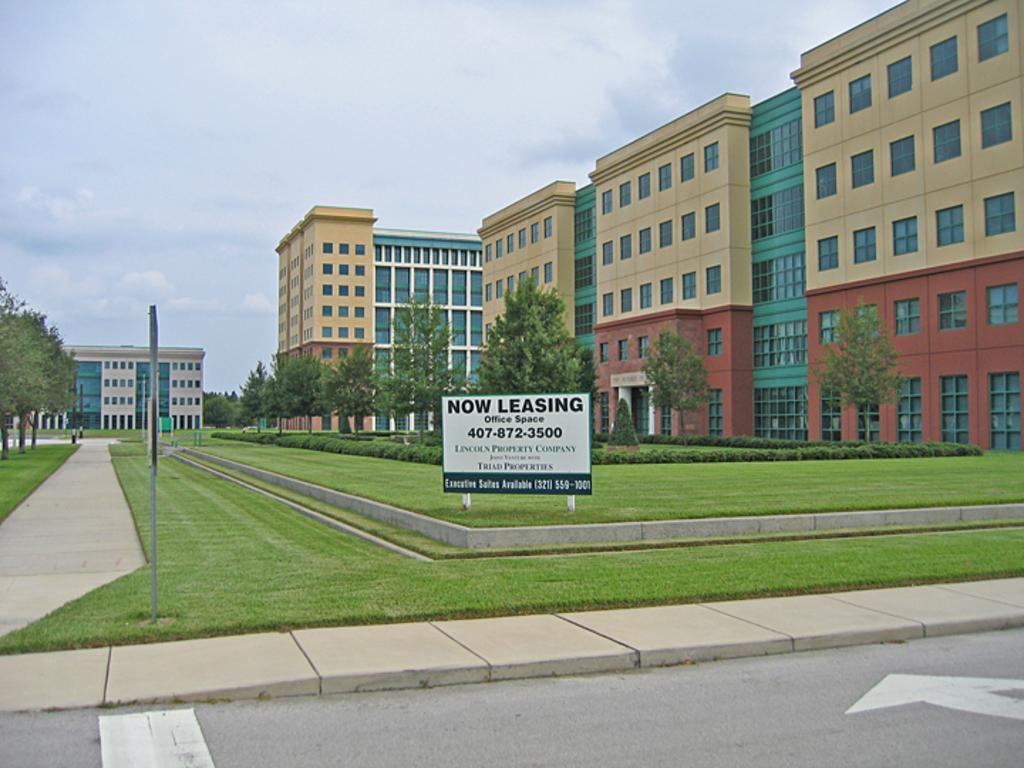Could you give a brief overview of what you see in this image? This image consists of buildings along with windows. At the bottom, there is a road. In the middle, we can see the green grass on the ground along with a board. On the left and right, there are trees. At the top, there are clouds in the sky. 